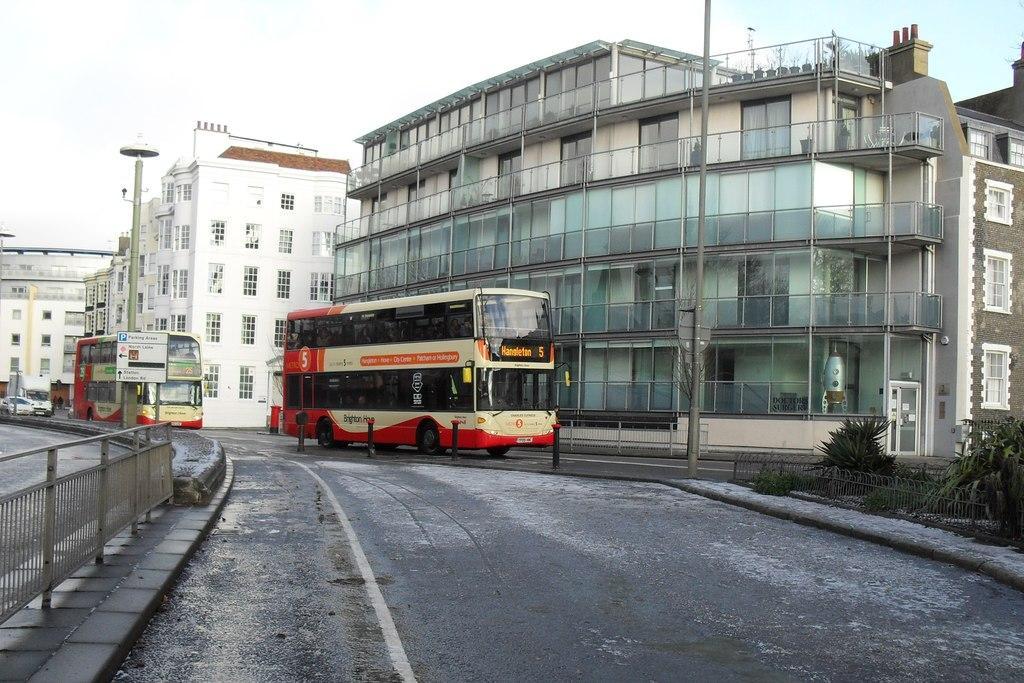Can you describe this image briefly? In this picture I can see Double Decker buses and vehicles on the road, there are plants, iron grilles, poles, there are buildings, and in the background there is the sky. 